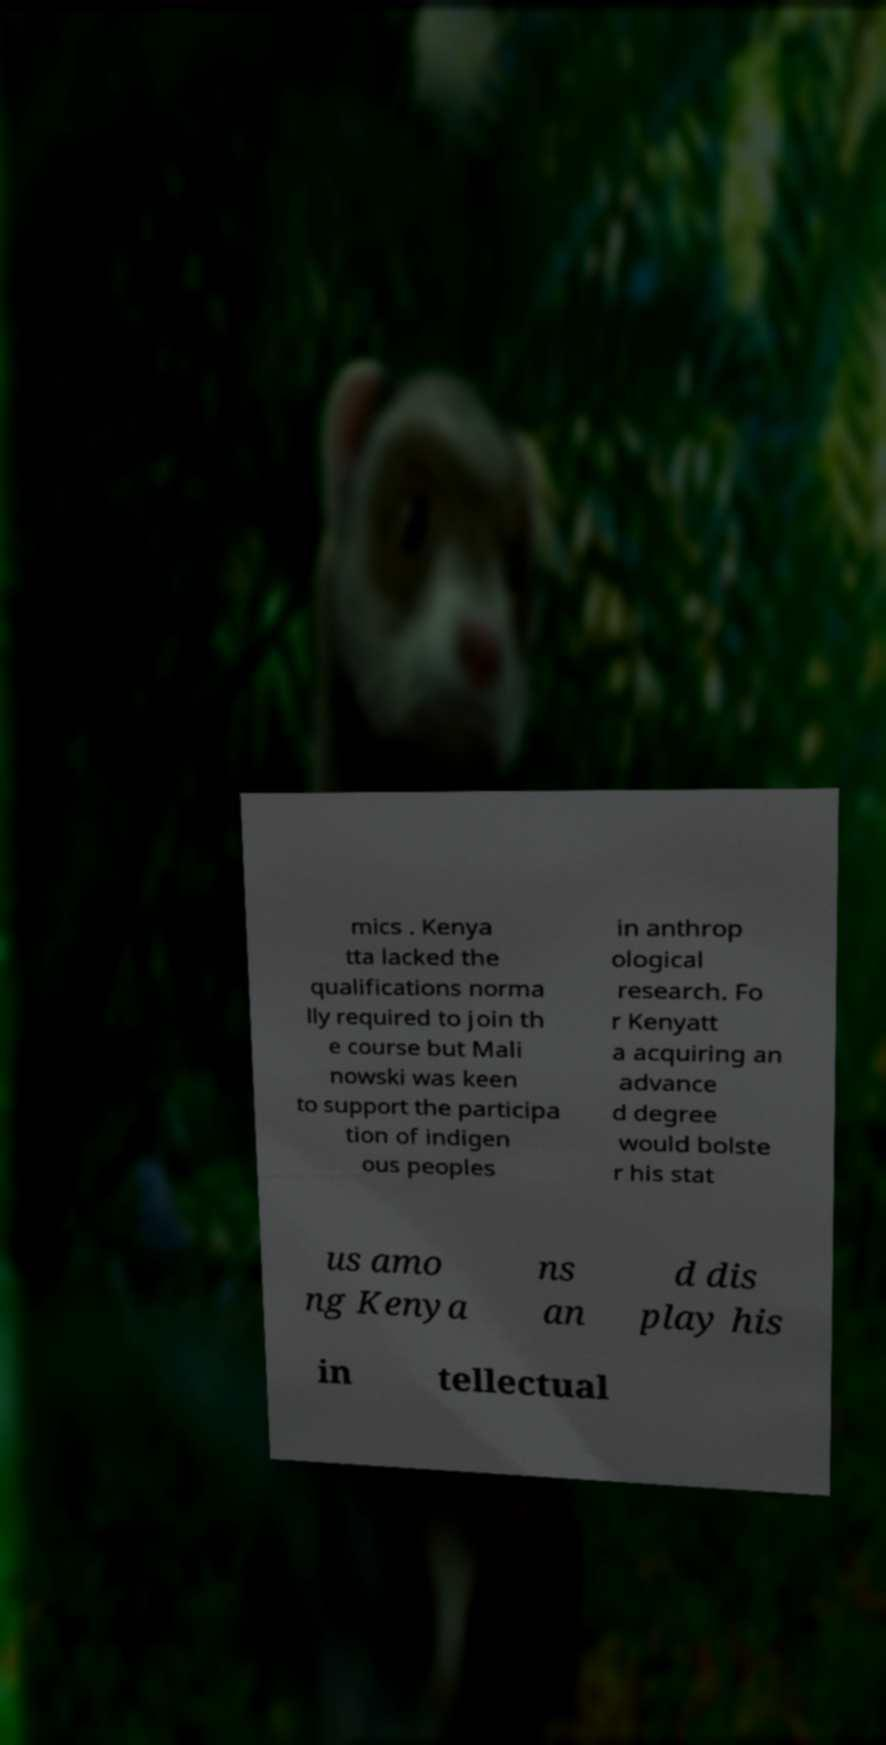Can you read and provide the text displayed in the image?This photo seems to have some interesting text. Can you extract and type it out for me? mics . Kenya tta lacked the qualifications norma lly required to join th e course but Mali nowski was keen to support the participa tion of indigen ous peoples in anthrop ological research. Fo r Kenyatt a acquiring an advance d degree would bolste r his stat us amo ng Kenya ns an d dis play his in tellectual 